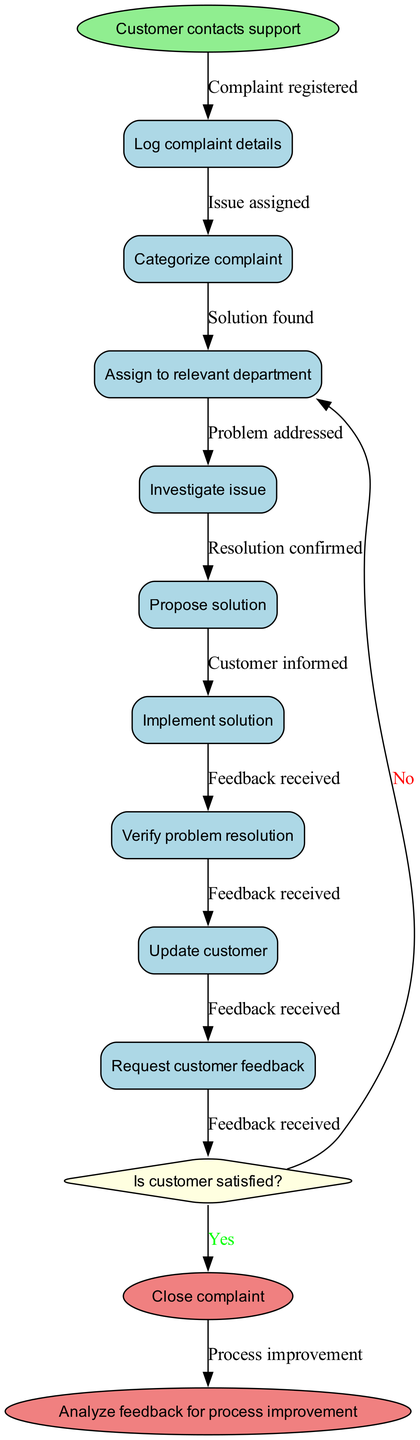What is the initial activity in the diagram? The initial activity as indicated by the first node is "Customer contacts support." This node represents the first step in the customer complaint resolution process.
Answer: Customer contacts support How many activities are mentioned in the diagram? The diagram lists eight activities in total, as outlined in the activities section. These include activities from "Log complaint details" to "Request customer feedback."
Answer: 8 What decision is made after proposing a solution? The decision made after proposing a solution is whether "Is customer satisfied?" This question determines the next step in the process based on customer satisfaction.
Answer: Is customer satisfied? What happens if the customer is not satisfied? If the customer is not satisfied, the flow directs to "Escalate to manager." This indicates that the issue requires further attention from a higher authority within the organization.
Answer: Escalate to manager What is the final node regarding feedback? The final node related to feedback is "Analyze feedback for process improvement." This shows that the feedback collected from the customer is being used to enhance future processes.
Answer: Analyze feedback for process improvement How many edges connect the activities in the diagram? The diagram has six edges that connect the various activities, indicating the flow from one activity to the next in the customer complaint resolution procedure.
Answer: 6 What is the outcome if the customer is satisfied? If the customer is satisfied, the outcome is to "Close complaint." This step indicates the resolution of the customer's issue and the formal closure of their complaint.
Answer: Close complaint What activity follows "Implement solution"? After "Implement solution," the next activity is "Verify problem resolution," indicating that the solution needs to be confirmed as effective before proceeding further.
Answer: Verify problem resolution 